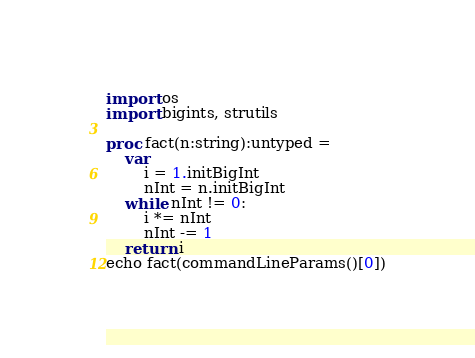<code> <loc_0><loc_0><loc_500><loc_500><_Nim_>import os
import bigints, strutils

proc fact(n:string):untyped =
    var
        i = 1.initBigInt
        nInt = n.initBigInt
    while nInt != 0:
        i *= nInt
        nInt -= 1
    return i
echo fact(commandLineParams()[0])
</code> 